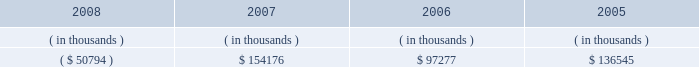Entergy texas , inc .
Management's financial discussion and analysis dividends or other distributions on its common stock .
Currently , all of entergy texas' retained earnings are available for distribution .
Sources of capital entergy texas' sources to meet its capital requirements include : internally generated funds ; cash on hand ; debt or preferred stock issuances ; and bank financing under new or existing facilities .
Entergy texas may refinance or redeem debt prior to maturity , to the extent market conditions and interest and dividend rates are favorable .
All debt and common and preferred stock issuances by entergy texas require prior regulatory approval .
Preferred stock and debt issuances are also subject to issuance tests set forth in its corporate charter , bond indentures , and other agreements .
Entergy texas has sufficient capacity under these tests to meet its foreseeable capital needs .
Entergy gulf states , inc .
Filed with the ferc an application , on behalf of entergy texas , for authority to issue up to $ 200 million of short-term debt , up to $ 300 million of tax-exempt bonds , and up to $ 1.3 billion of other long- term securities , including common and preferred or preference stock and long-term debt .
On november 8 , 2007 , the ferc issued orders granting the requested authority for a two-year period ending november 8 , 2009 .
Entergy texas' receivables from or ( payables to ) the money pool were as follows as of december 31 for each of the following years: .
See note 4 to the financial statements for a description of the money pool .
Entergy texas has a credit facility in the amount of $ 100 million scheduled to expire in august 2012 .
As of december 31 , 2008 , $ 100 million was outstanding on the credit facility .
In february 2009 , entergy texas repaid its credit facility with the proceeds from the bond issuance discussed below .
On june 2 , 2008 and december 8 , 2008 , under the terms of the debt assumption agreement between entergy texas and entergy gulf states louisiana that is discussed in note 5 to the financial statements , entergy texas paid at maturity $ 148.8 million and $ 160.3 million , respectively , of entergy gulf states louisiana first mortgage bonds , which results in a corresponding decrease in entergy texas' debt assumption liability .
In december 2008 , entergy texas borrowed $ 160 million from its parent company , entergy corporation , under a $ 300 million revolving credit facility pursuant to an inter-company credit agreement between entergy corporation and entergy texas .
This borrowing would have matured on december 3 , 2013 .
Entergy texas used these borrowings , together with other available corporate funds , to pay at maturity the portion of the $ 350 million floating rate series of first mortgage bonds due december 2008 that had been assumed by entergy texas , and that bond series is no longer outstanding .
In january 2009 , entergy texas repaid its $ 160 million note payable to entergy corporation with the proceeds from the bond issuance discussed below .
In january 2009 , entergy texas issued $ 500 million of 7.125% ( 7.125 % ) series mortgage bonds due february 2019 .
Entergy texas used a portion of the proceeds to repay its $ 160 million note payable to entergy corporation , to repay the $ 100 million outstanding on its credit facility , and to repay short-term borrowings under the entergy system money pool .
Entergy texas intends to use the remaining proceeds to repay on or prior to maturity approximately $ 70 million of obligations that had been assumed by entergy texas under the debt assumption agreement with entergy gulf states louisiana and for other general corporate purposes. .
What portion of the proceeds from the series mortgage bonds issued in january 2009 were used to repay the note payable to entergy corporation? 
Computations: (160 / 500)
Answer: 0.32. 